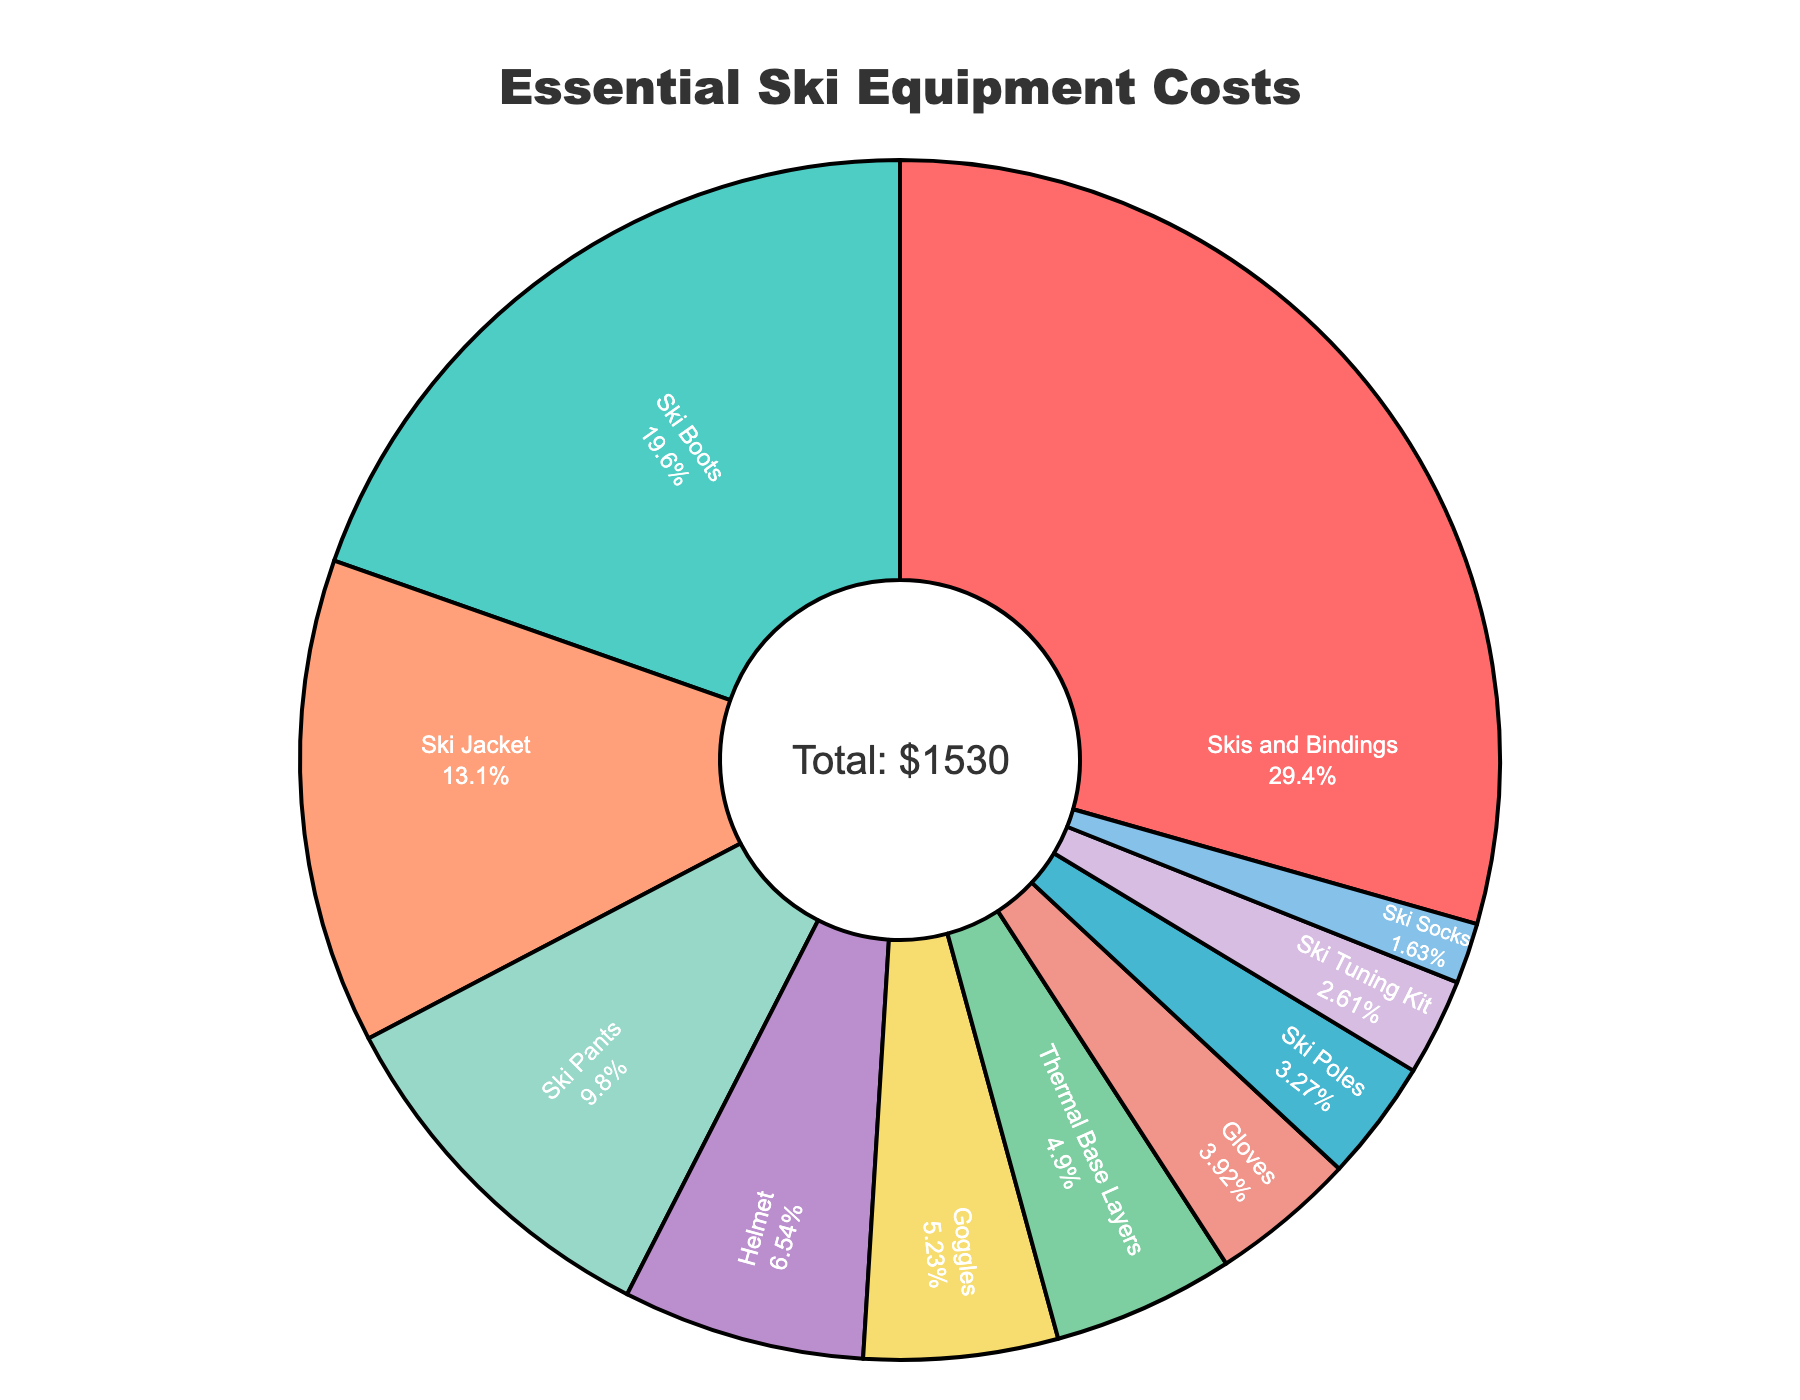What is the cost of Ski Boots? The figure shows the costs of various ski equipment, and Ski Boots are listed with their cost.
Answer: 300 Which item has the highest cost? By observing all the costs displayed in the figure, the item with the highest cost can be identified.
Answer: Skis and Bindings Which is more expensive, Ski Jacket or Ski Pants? By comparing the costs of Ski Jacket (200) and Ski Pants (150), we can determine which one is higher.
Answer: Ski Jacket What is the combined cost of Goggles and Helmet? Adding the cost of Goggles (80) and Helmet (100) gives us the total. 80 + 100 = 180
Answer: 180 How many categories have a cost of less than $100? By counting the categories with costs below $100: Ski Poles (50), Goggles (80), Helmet (100), Thermal Base Layers (75), Gloves (60), Ski Socks (25), and Ski Tuning Kit (40), there are six categories.
Answer: 6 What percentage of the total cost is attributed to Skis and Bindings? The total cost is summed up, and the percentage is calculated as (450 / 1530) * 100.
Answer: 29.41% What is the total cost of all the essential ski equipment listed? Summing up all the individual costs: 450 + 300 + 50 + 200 + 150 + 80 + 100 + 75 + 60 + 25 + 40 = 1530.
Answer: 1530 Is the cost of Ski Jacket and Ski Pants combined greater than the cost of Skis and Bindings? Adding Ski Jacket (200) and Ski Pants (150) gives 350, which is less than Skis and Bindings (450).
Answer: No Which category has the smallest cost? By comparing all the costs, the category with the smallest cost can be identified.
Answer: Ski Socks If you were to buy two Ski Tuning Kits, what would the total cost be? Multiply the cost of one Ski Tuning Kit (40) by 2: 40 * 2 = 80.
Answer: 80 